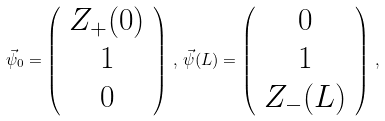Convert formula to latex. <formula><loc_0><loc_0><loc_500><loc_500>\vec { \psi } _ { 0 } = \left ( \begin{array} { c } Z _ { + } ( 0 ) \\ 1 \\ 0 \end{array} \right ) \, , \, \vec { \psi } ( L ) = \left ( \begin{array} { c } 0 \\ 1 \\ Z _ { - } ( L ) \end{array} \right ) \, ,</formula> 